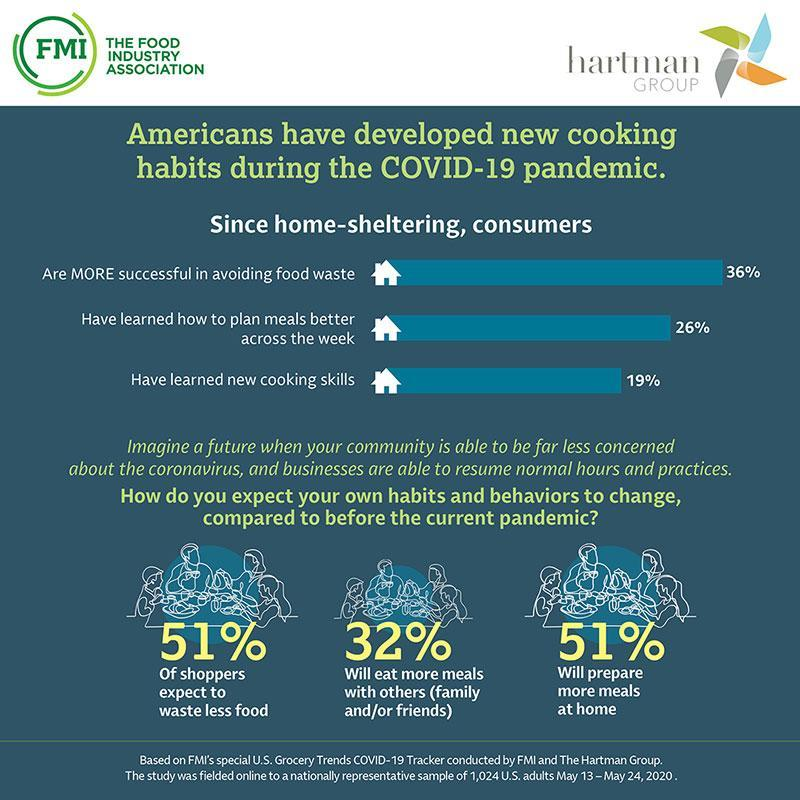What skill has 19% of the consumers developed
Answer the question with a short phrase. learned new cooking skills What % of people will prepared more meals at home than before the current pandemic 51% What % will eat more meals with others (family and/or friends) 32 